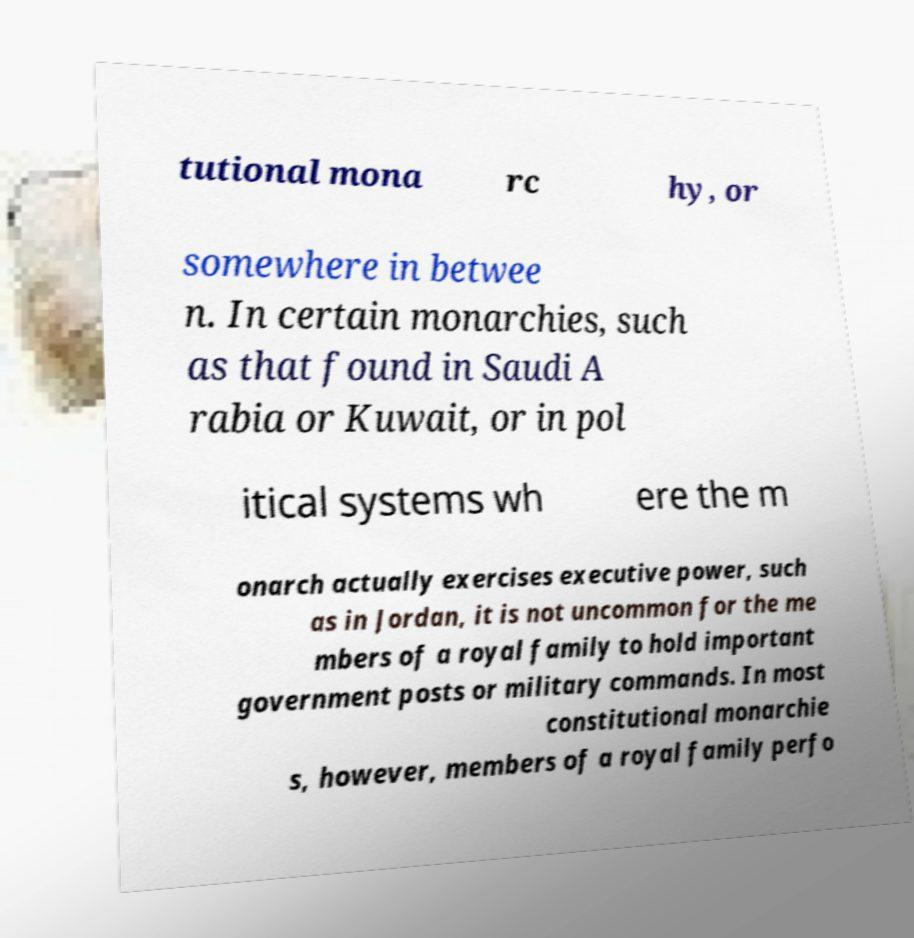I need the written content from this picture converted into text. Can you do that? tutional mona rc hy, or somewhere in betwee n. In certain monarchies, such as that found in Saudi A rabia or Kuwait, or in pol itical systems wh ere the m onarch actually exercises executive power, such as in Jordan, it is not uncommon for the me mbers of a royal family to hold important government posts or military commands. In most constitutional monarchie s, however, members of a royal family perfo 